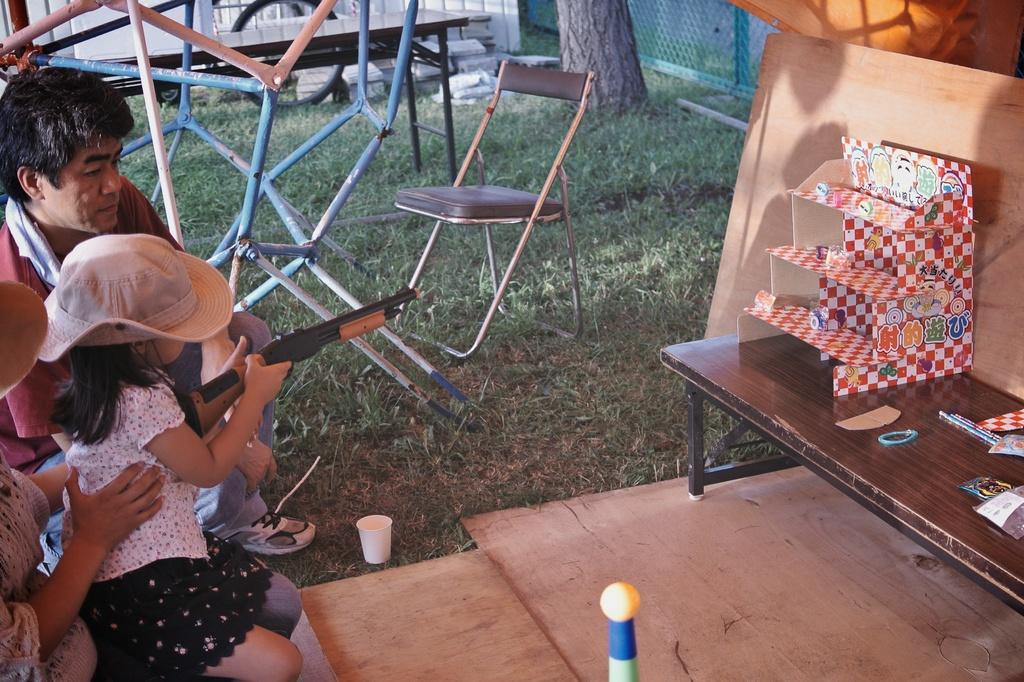Who is the main subject in the image? There is a girl in the image. What is the girl doing in the image? The girl is aiming an object in the image. Where is the object placed? The object is placed on a table. What can be seen in the background of the image? There is an unoccupied chair and a tree visible in the background of the image. What is the girl's belief about the upcoming addition to her family in the image? There is no information about the girl's beliefs or an upcoming addition to her family in the image. How does the earthquake affect the girl's aiming of the object in the image? There is no earthquake present in the image, so it does not affect the girl's aiming of the object. 